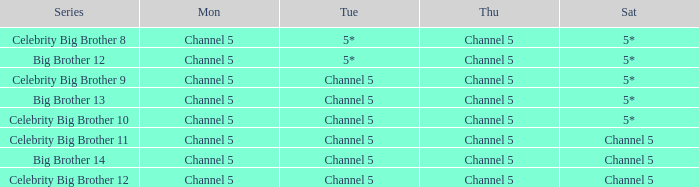Which Tuesday does big brother 12 air? 5*. 